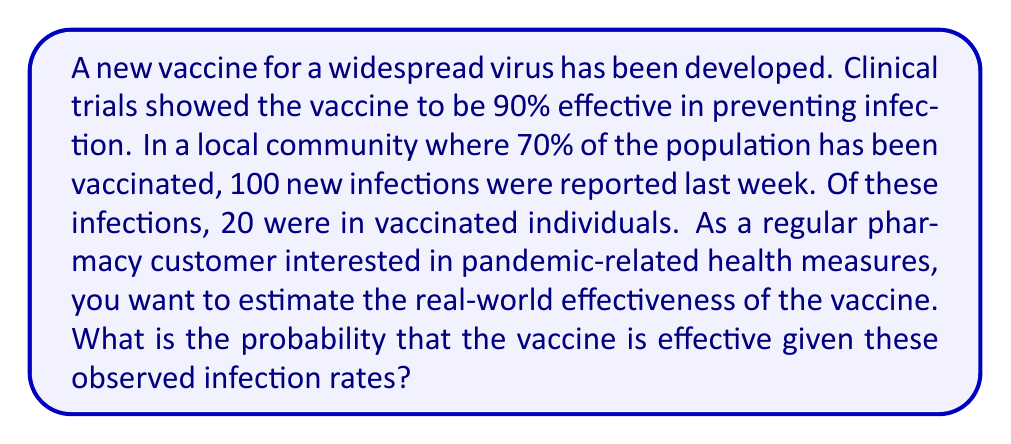Give your solution to this math problem. To solve this problem, we'll use Bayes' theorem. Let's define our events:

$E$: The vaccine is effective
$I$: A person is infected

We want to find $P(E|I)$, the probability that the vaccine is effective given that a person is infected.

Bayes' theorem states:

$$P(E|I) = \frac{P(I|E) \cdot P(E)}{P(I)}$$

Let's break down each component:

1. $P(E)$: Prior probability of the vaccine being effective. From clinical trials, we know this is 0.90.

2. $P(I|E)$: Probability of infection given the vaccine is effective. 
   In the vaccinated population (70% of 100 = 70 people), 20 were infected.
   So, $P(I|E) = 20/70 = 2/7 \approx 0.2857$

3. $P(I)$: Total probability of infection.
   Total infections / Total population = 100/100 = 1

Now, let's plug these values into Bayes' theorem:

$$P(E|I) = \frac{0.2857 \cdot 0.90}{1} \approx 0.2571$$

Therefore, the probability that the vaccine is effective given the observed infection rates is approximately 0.2571 or 25.71%.

This lower probability compared to the clinical trials (90%) suggests that the real-world effectiveness might be lower than initially thought, which is not uncommon due to various factors such as new virus variants, different population demographics, or imperfect adherence to vaccination protocols.
Answer: The probability that the vaccine is effective given the observed infection rates is approximately 0.2571 or 25.71%. 